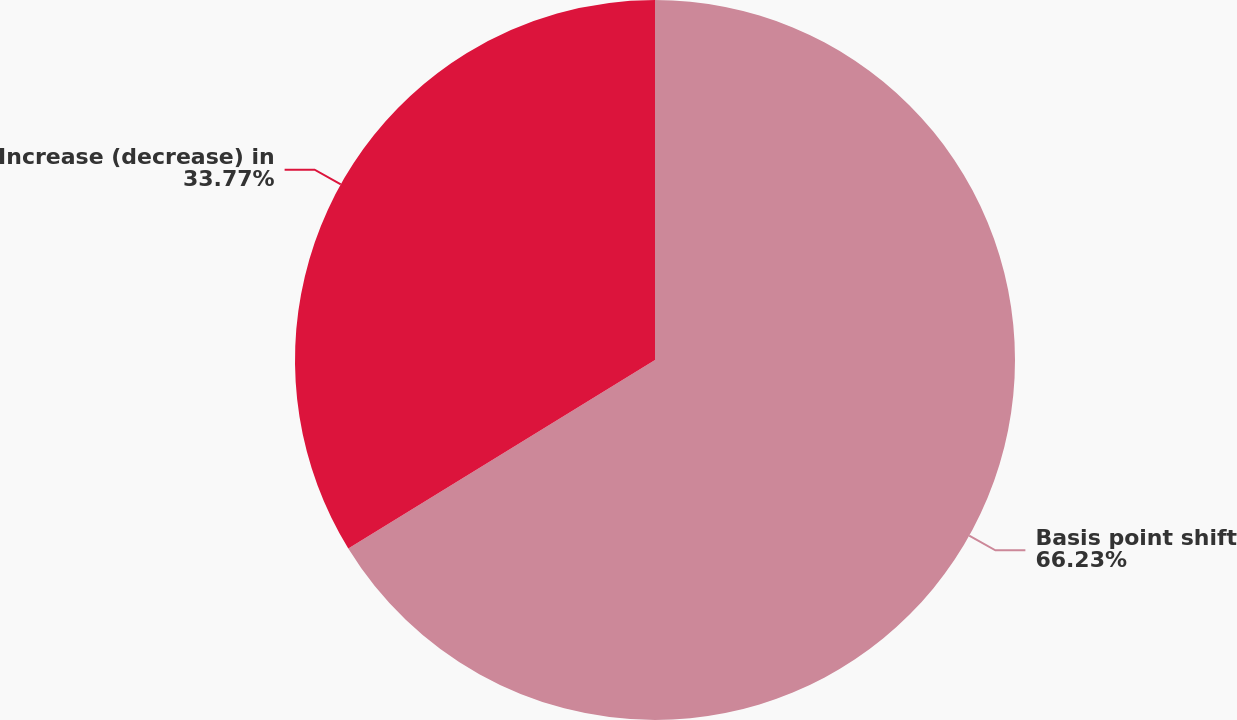Convert chart to OTSL. <chart><loc_0><loc_0><loc_500><loc_500><pie_chart><fcel>Basis point shift<fcel>Increase (decrease) in<nl><fcel>66.23%<fcel>33.77%<nl></chart> 